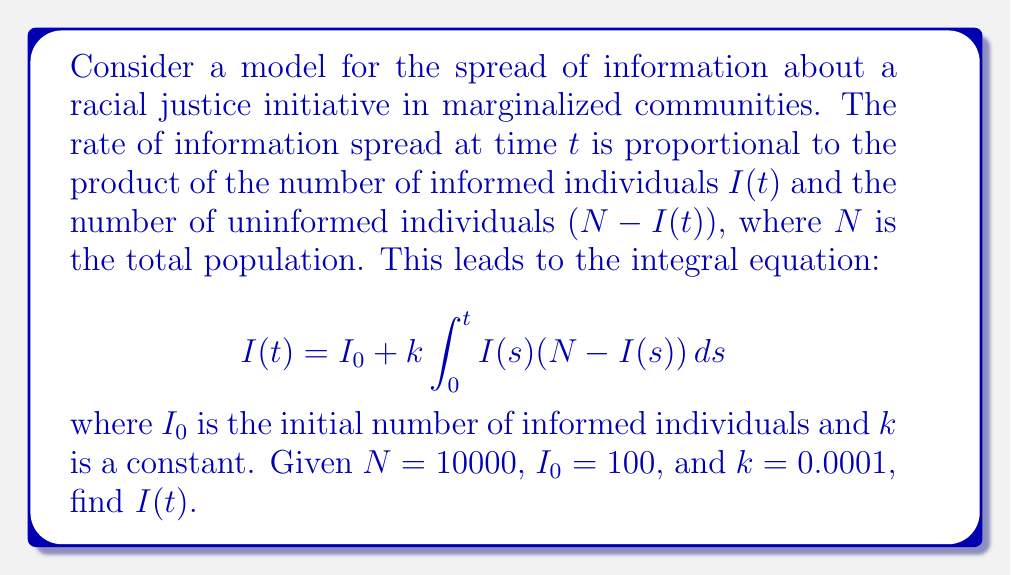Give your solution to this math problem. To solve this integral equation, we'll follow these steps:

1) First, we recognize this as a Volterra integral equation of the second kind.

2) The equation represents a logistic growth model, which has a known solution.

3) We can convert this integral equation to a differential equation by differentiating both sides with respect to $t$:

   $$\frac{dI}{dt} = kI(N - I)$$

4) This is a separable differential equation. We can solve it as follows:

   $$\int \frac{dI}{I(N-I)} = kt + C$$

5) The left-hand side integrates to:

   $$-\frac{1}{N} \ln\left(\frac{N-I}{I}\right) = kt + C$$

6) Solving for $I(t)$:

   $$I(t) = \frac{N}{1 + Ce^{-kNt}}$$

7) To find $C$, we use the initial condition $I(0) = I_0$:

   $$I_0 = \frac{N}{1 + C}$$

   $$C = \frac{N - I_0}{I_0}$$

8) Substituting the given values $N = 10000$, $I_0 = 100$, and $k = 0.0001$:

   $$C = \frac{10000 - 100}{100} = 99$$

9) Therefore, the final solution is:

   $$I(t) = \frac{10000}{1 + 99e^{-t}}$$
Answer: $I(t) = \frac{10000}{1 + 99e^{-t}}$ 